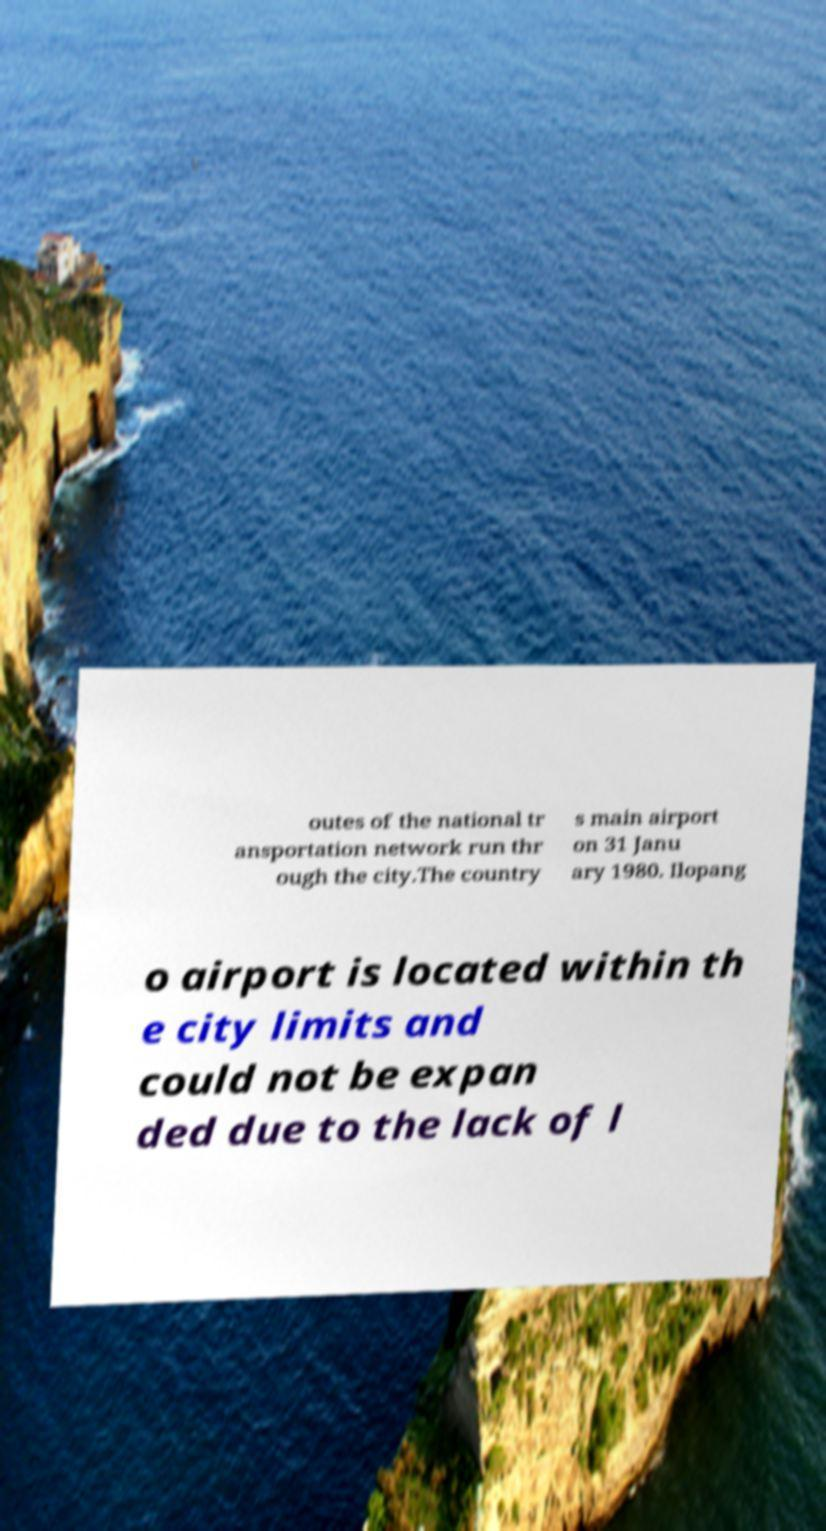Could you assist in decoding the text presented in this image and type it out clearly? outes of the national tr ansportation network run thr ough the city.The country s main airport on 31 Janu ary 1980. Ilopang o airport is located within th e city limits and could not be expan ded due to the lack of l 